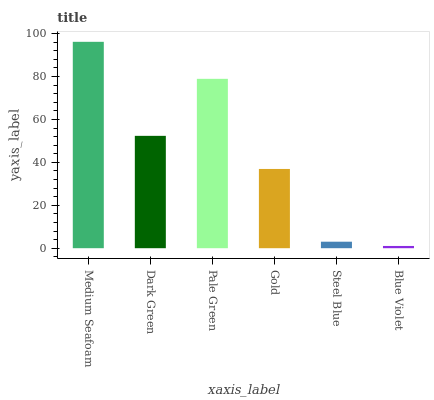Is Blue Violet the minimum?
Answer yes or no. Yes. Is Medium Seafoam the maximum?
Answer yes or no. Yes. Is Dark Green the minimum?
Answer yes or no. No. Is Dark Green the maximum?
Answer yes or no. No. Is Medium Seafoam greater than Dark Green?
Answer yes or no. Yes. Is Dark Green less than Medium Seafoam?
Answer yes or no. Yes. Is Dark Green greater than Medium Seafoam?
Answer yes or no. No. Is Medium Seafoam less than Dark Green?
Answer yes or no. No. Is Dark Green the high median?
Answer yes or no. Yes. Is Gold the low median?
Answer yes or no. Yes. Is Medium Seafoam the high median?
Answer yes or no. No. Is Dark Green the low median?
Answer yes or no. No. 